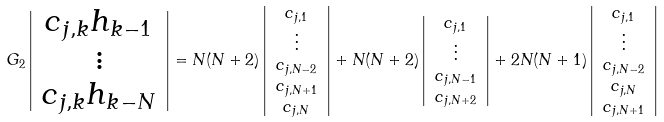Convert formula to latex. <formula><loc_0><loc_0><loc_500><loc_500>G _ { 2 } \left | \begin{array} { c } c _ { j , k } h _ { k - 1 } \\ \vdots \\ c _ { j , k } h _ { k - N } \end{array} \right | & = N ( N + 2 ) \left | \begin{array} { c } c _ { j , 1 } \\ \vdots \\ c _ { j , N - 2 } \\ c _ { j , N + 1 } \\ c _ { j , N } \end{array} \right | + N ( N + 2 ) \left | \begin{array} { c } c _ { j , 1 } \\ \vdots \\ c _ { j , N - 1 } \\ c _ { j , N + 2 } \end{array} \right | + 2 N ( N + 1 ) \left | \begin{array} { c } c _ { j , 1 } \\ \vdots \\ c _ { j , N - 2 } \\ c _ { j , N } \\ c _ { j , N + 1 } \end{array} \right |</formula> 